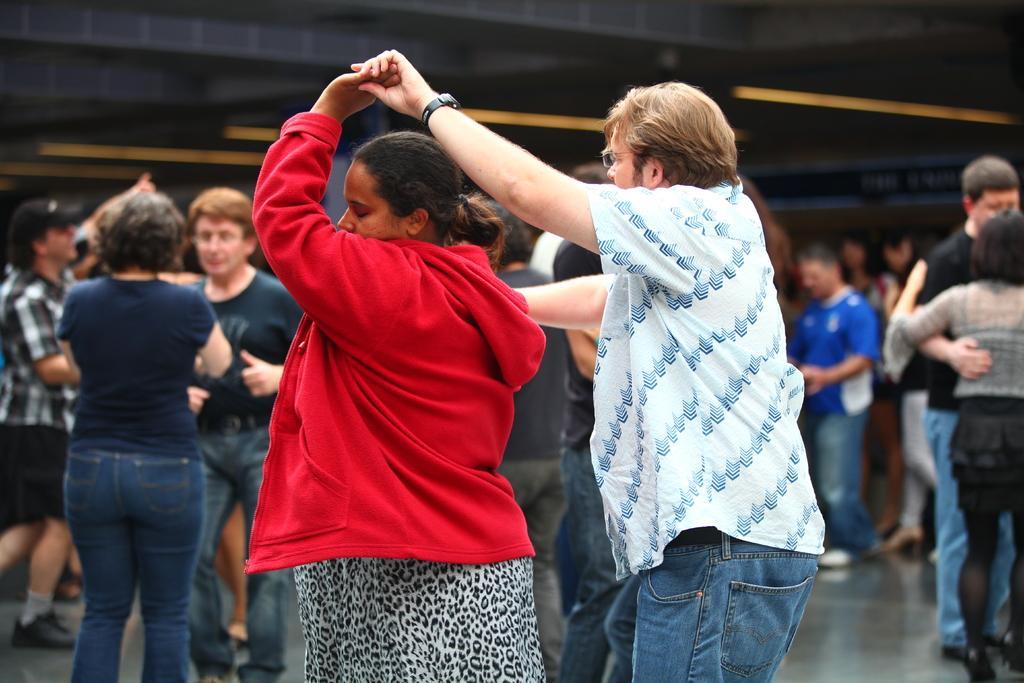Could you give a brief overview of what you see in this image? In this picture we can see a group of people on the floor and some objects. 